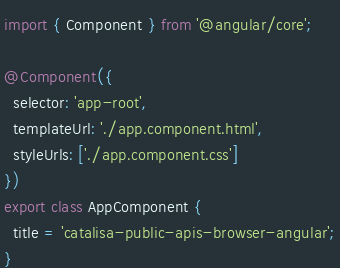<code> <loc_0><loc_0><loc_500><loc_500><_TypeScript_>import { Component } from '@angular/core';

@Component({
  selector: 'app-root',
  templateUrl: './app.component.html',
  styleUrls: ['./app.component.css']
})
export class AppComponent {
  title = 'catalisa-public-apis-browser-angular';
}
</code> 